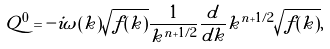<formula> <loc_0><loc_0><loc_500><loc_500>Q ^ { 0 } = - i \omega ( k ) \sqrt { f ( k ) } \frac { 1 } { k ^ { n + 1 / 2 } } \frac { d } { d k } k ^ { n + 1 / 2 } \sqrt { f ( k ) } ,</formula> 